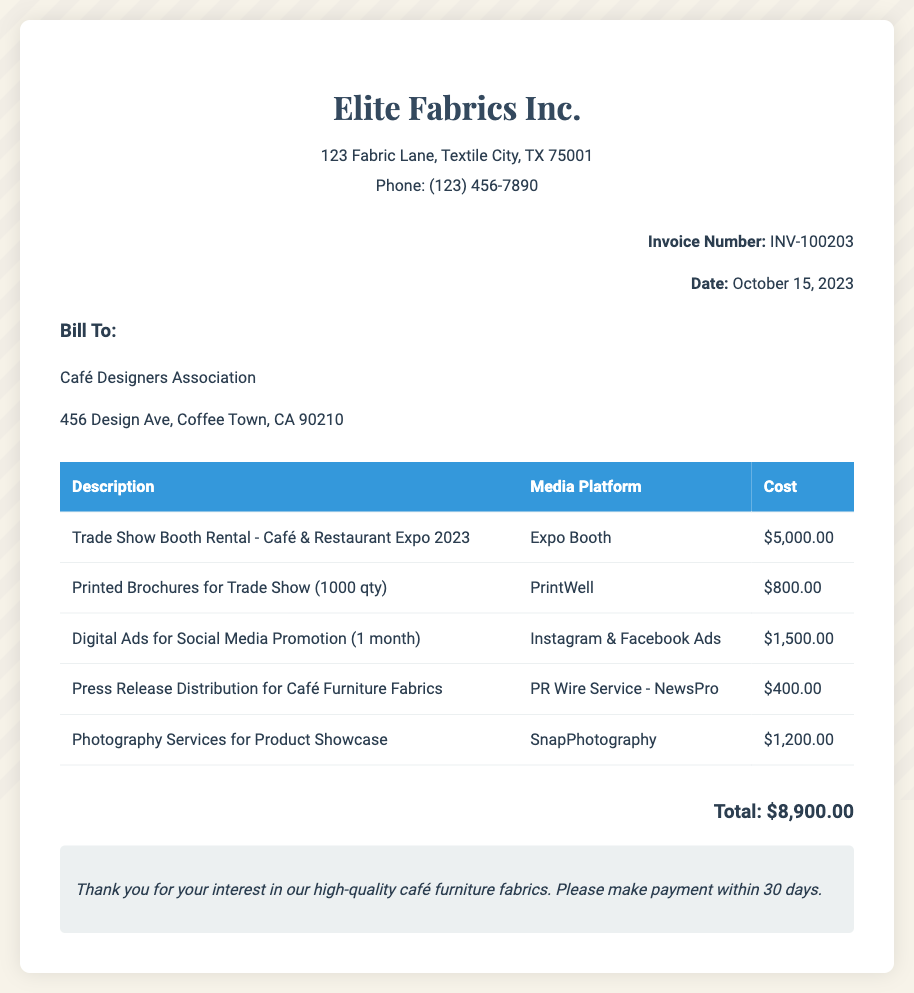What is the invoice number? The invoice number is located in the invoice details section at the top right of the document.
Answer: INV-100203 What is the date of the invoice? The date of the invoice is mentioned in the invoice details section beneath the invoice number.
Answer: October 15, 2023 Who is the recipient of the bill? The recipient is listed in the "Bill To" section of the document.
Answer: Café Designers Association What was the cost of the trade show booth rental? The cost is listed in the table under the description "Trade Show Booth Rental - Café & Restaurant Expo 2023."
Answer: $5,000.00 What is the total amount due? The total amount is listed in the total section at the bottom of the document.
Answer: $8,900.00 How many printed brochures were made for the trade show? The quantity is specified in the description of the printed brochures.
Answer: 1000 qty Which media platform was used for digital ads? The media platform for the digital ads is stated in the table under the corresponding description.
Answer: Instagram & Facebook Ads What is the service that provided press release distribution? The service is mentioned in the costs section associated with press release distribution.
Answer: PR Wire Service - NewsPro What is the note about payment terms? The note highlights the required action regarding payment timeframes at the bottom of the document.
Answer: Please make payment within 30 days 